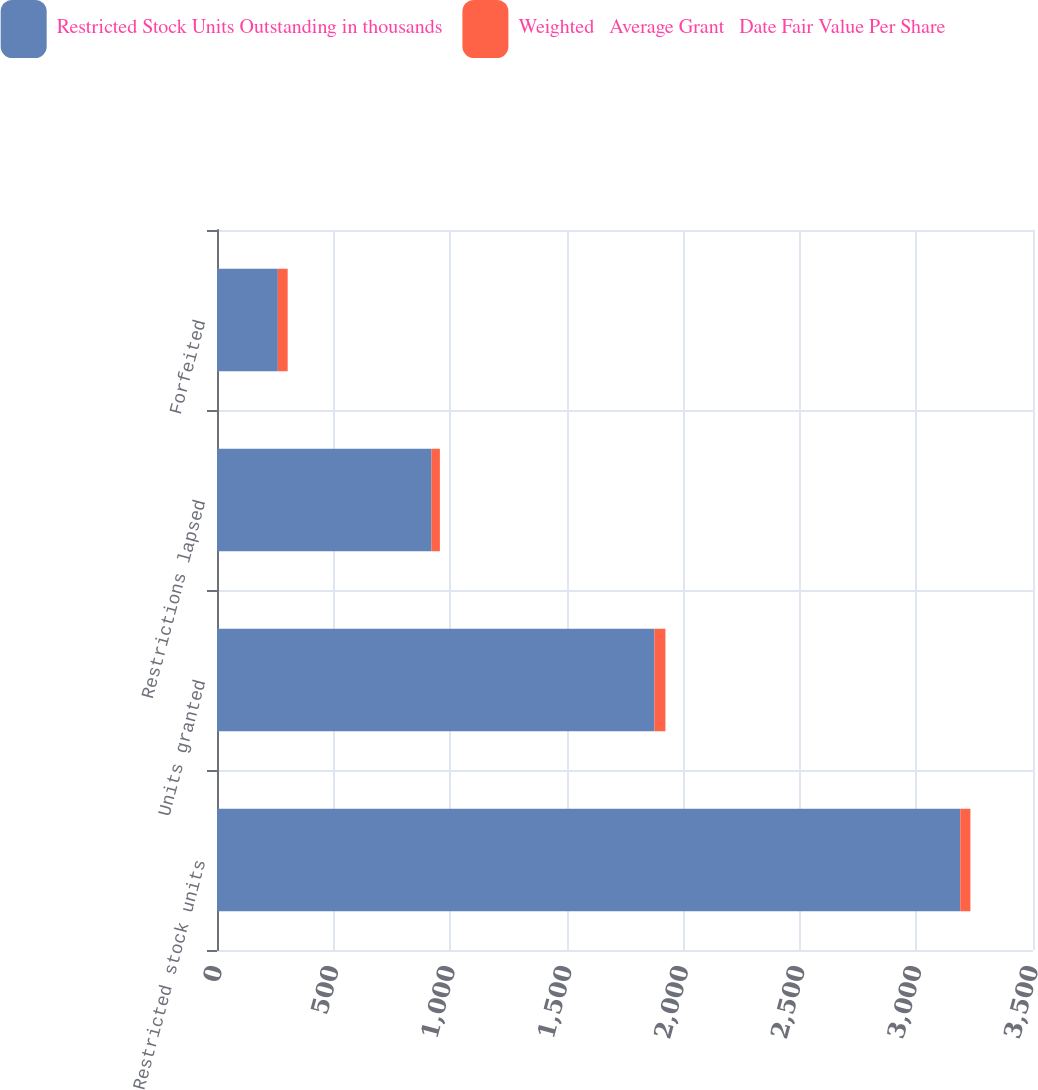<chart> <loc_0><loc_0><loc_500><loc_500><stacked_bar_chart><ecel><fcel>Restricted stock units<fcel>Units granted<fcel>Restrictions lapsed<fcel>Forfeited<nl><fcel>Restricted Stock Units Outstanding in thousands<fcel>3188<fcel>1876<fcel>920<fcel>261<nl><fcel>Weighted   Average Grant   Date Fair Value Per Share<fcel>43.46<fcel>47.38<fcel>36.02<fcel>42.1<nl></chart> 